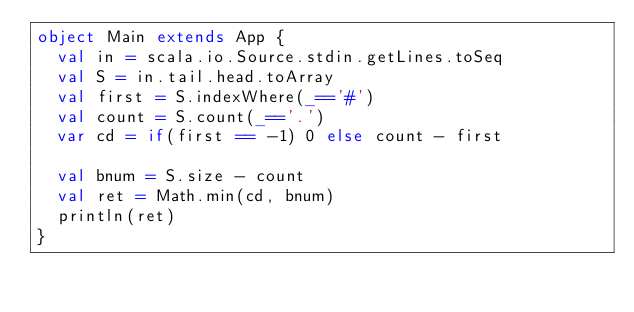<code> <loc_0><loc_0><loc_500><loc_500><_Scala_>object Main extends App {
  val in = scala.io.Source.stdin.getLines.toSeq
  val S = in.tail.head.toArray
  val first = S.indexWhere(_=='#')
  val count = S.count(_=='.')
  var cd = if(first == -1) 0 else count - first  

  val bnum = S.size - count
  val ret = Math.min(cd, bnum)
  println(ret)
}
</code> 